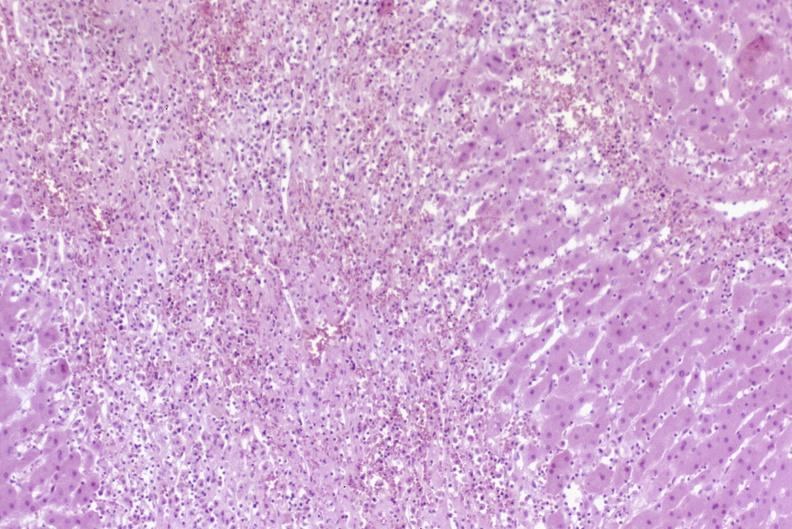does this image show severe acute rejection?
Answer the question using a single word or phrase. Yes 